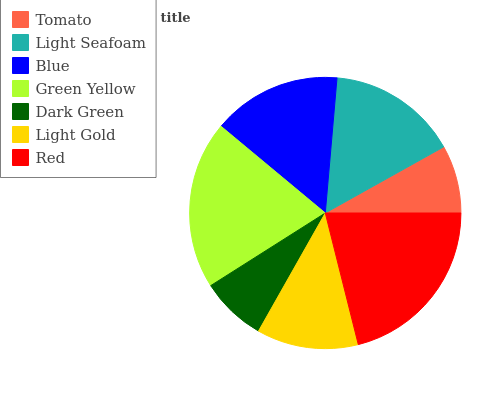Is Dark Green the minimum?
Answer yes or no. Yes. Is Red the maximum?
Answer yes or no. Yes. Is Light Seafoam the minimum?
Answer yes or no. No. Is Light Seafoam the maximum?
Answer yes or no. No. Is Light Seafoam greater than Tomato?
Answer yes or no. Yes. Is Tomato less than Light Seafoam?
Answer yes or no. Yes. Is Tomato greater than Light Seafoam?
Answer yes or no. No. Is Light Seafoam less than Tomato?
Answer yes or no. No. Is Blue the high median?
Answer yes or no. Yes. Is Blue the low median?
Answer yes or no. Yes. Is Green Yellow the high median?
Answer yes or no. No. Is Light Seafoam the low median?
Answer yes or no. No. 